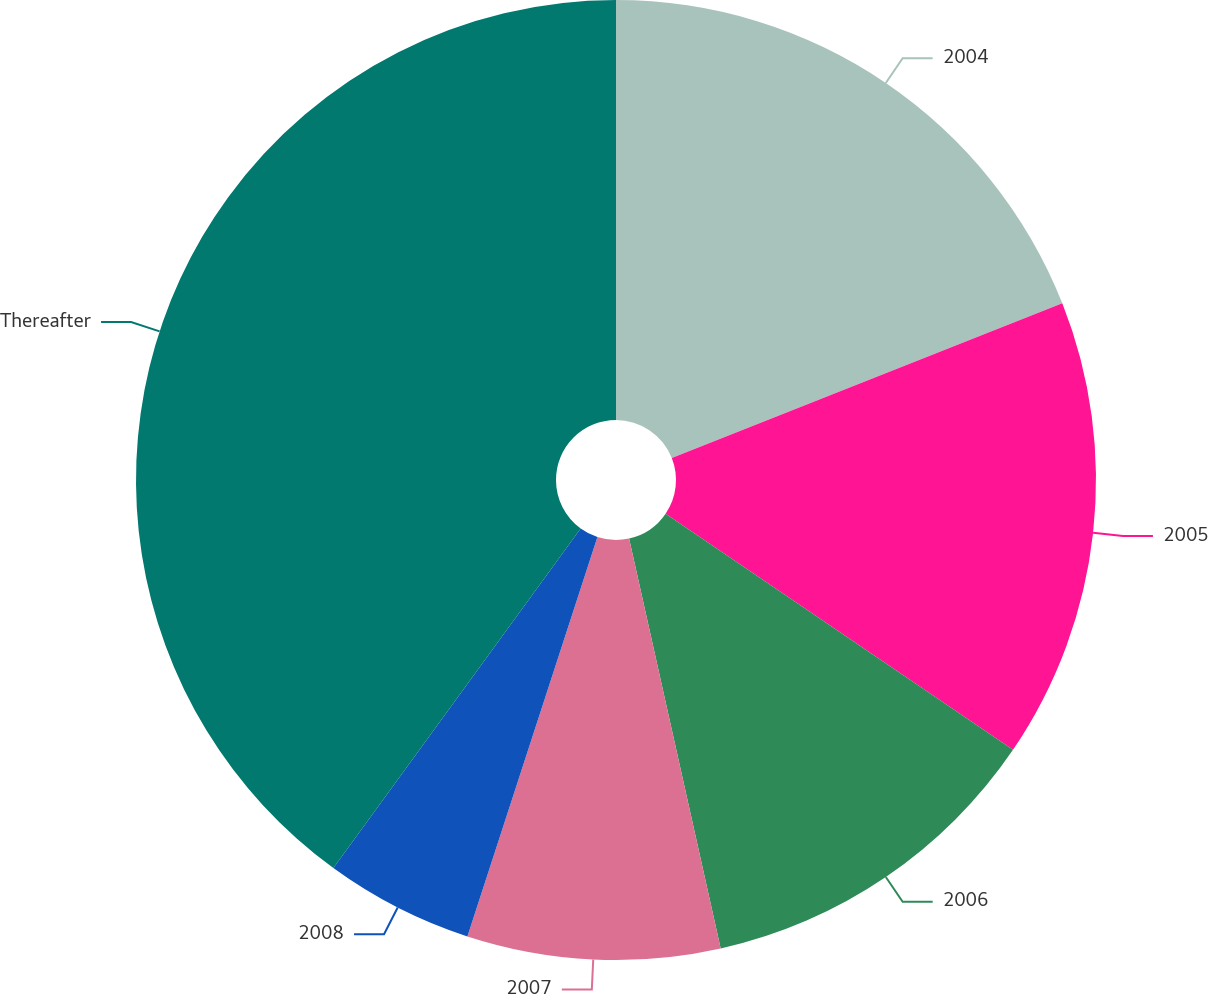Convert chart to OTSL. <chart><loc_0><loc_0><loc_500><loc_500><pie_chart><fcel>2004<fcel>2005<fcel>2006<fcel>2007<fcel>2008<fcel>Thereafter<nl><fcel>19.0%<fcel>15.5%<fcel>12.0%<fcel>8.51%<fcel>5.01%<fcel>39.98%<nl></chart> 